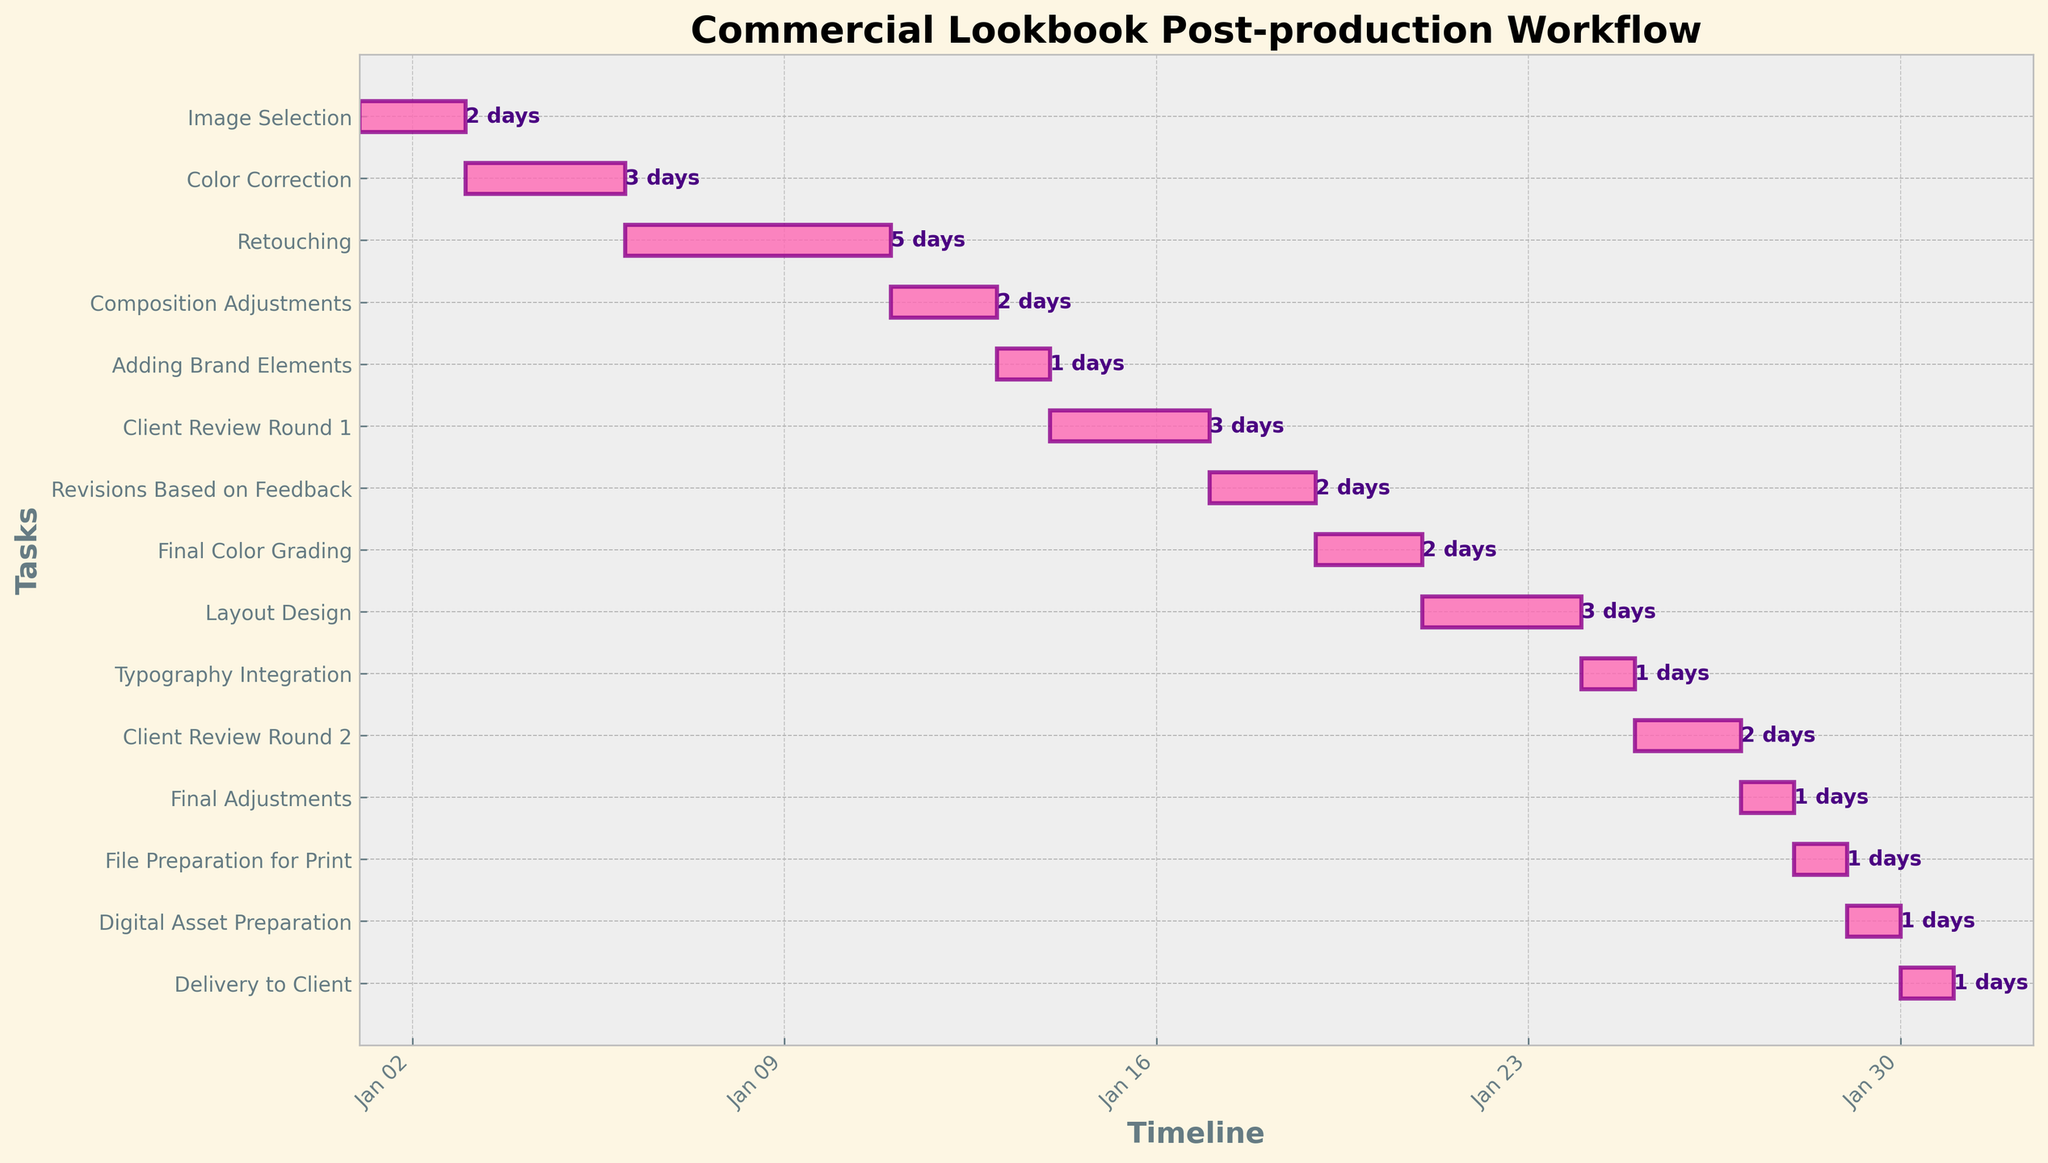What's the start date of the "Color Correction" task? The start date can be directly observed from the figure. Look at the horizontal bar corresponding to the "Color Correction" task and check the date on the x-axis.
Answer: Jan 3 How many days does the "Retouching" task span? The duration of the task is labeled at the end of each bar. Locate the "Retouching" task and read the label.
Answer: 5 days Which task immediately follows "Image Selection"? Look at the tasks ordered chronologically in the Gantt chart. The task that starts right after "Image Selection" finishes is the one that immediately follows.
Answer: Color Correction What is the total duration from the start of "Image Selection" to the start of "Adding Brand Elements"? Calculate the duration between the start of "Image Selection" (Jan 1) and the start of "Adding Brand Elements" (Jan 13).
Answer: 12 days Compare the durations of "Final Color Grading" and "Typography Integration". Which one takes longer? Compare the duration labels for the "Final Color Grading" and "Typography Integration" tasks.
Answer: Final Color Grading What's the latest task in the workflow? Identify the task that starts last in the Gantt chart.
Answer: Delivery to Client During which dates does the "Client Review Round 1" take place? Check the start and end date for the "Client Review Round 1" bar on the chart.
Answer: Jan 14 to Jan 17 How much time passes between the completion of "Retouching" and the start of "Composition Adjustments"? Calculate the difference between the end date of "Retouching" and the start date of "Composition Adjustments".
Answer: 1 day What percentage of the entire workflow is dedicated to "Layout Design"? Calculate the percentage by comparing the duration of "Layout Design" with the total duration of the entire workflow. The workflow starts on Jan 1 and ends on Jan 30, totaling 30 days. "Layout Design" spans 3 days.
Answer: 10% Does "Revisions Based on Feedback" overlap with "Final Color Grading"? Check the dates for both tasks to see if they occupy any of the same dates on the Gantt chart.
Answer: No 